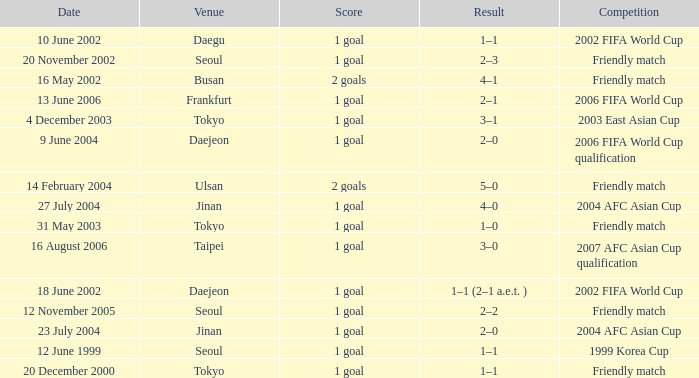What was the score of the game played on 16 August 2006? 1 goal. 